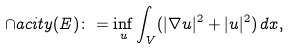Convert formula to latex. <formula><loc_0><loc_0><loc_500><loc_500>\cap a c i t y ( E ) \colon = \inf _ { u } \int _ { V } ( | \nabla u | ^ { 2 } + | u | ^ { 2 } ) \, d x ,</formula> 